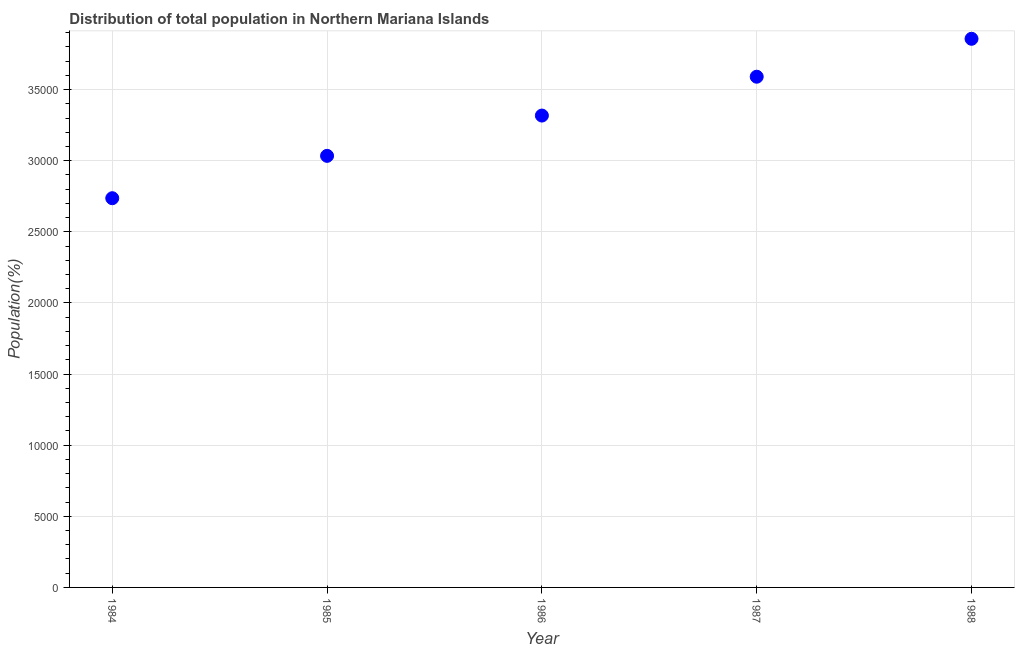What is the population in 1986?
Your answer should be compact. 3.32e+04. Across all years, what is the maximum population?
Your answer should be very brief. 3.86e+04. Across all years, what is the minimum population?
Offer a very short reply. 2.74e+04. In which year was the population maximum?
Give a very brief answer. 1988. What is the sum of the population?
Keep it short and to the point. 1.65e+05. What is the difference between the population in 1985 and 1986?
Offer a very short reply. -2832. What is the average population per year?
Provide a short and direct response. 3.31e+04. What is the median population?
Offer a very short reply. 3.32e+04. In how many years, is the population greater than 11000 %?
Your response must be concise. 5. Do a majority of the years between 1987 and 1985 (inclusive) have population greater than 24000 %?
Your answer should be compact. No. What is the ratio of the population in 1985 to that in 1988?
Ensure brevity in your answer.  0.79. Is the difference between the population in 1986 and 1987 greater than the difference between any two years?
Offer a terse response. No. What is the difference between the highest and the second highest population?
Provide a succinct answer. 2666. What is the difference between the highest and the lowest population?
Offer a terse response. 1.12e+04. Does the population monotonically increase over the years?
Offer a terse response. Yes. How many years are there in the graph?
Provide a succinct answer. 5. What is the difference between two consecutive major ticks on the Y-axis?
Ensure brevity in your answer.  5000. Does the graph contain any zero values?
Ensure brevity in your answer.  No. What is the title of the graph?
Your answer should be very brief. Distribution of total population in Northern Mariana Islands . What is the label or title of the Y-axis?
Provide a short and direct response. Population(%). What is the Population(%) in 1984?
Make the answer very short. 2.74e+04. What is the Population(%) in 1985?
Offer a terse response. 3.03e+04. What is the Population(%) in 1986?
Provide a short and direct response. 3.32e+04. What is the Population(%) in 1987?
Ensure brevity in your answer.  3.59e+04. What is the Population(%) in 1988?
Provide a short and direct response. 3.86e+04. What is the difference between the Population(%) in 1984 and 1985?
Ensure brevity in your answer.  -2978. What is the difference between the Population(%) in 1984 and 1986?
Provide a short and direct response. -5810. What is the difference between the Population(%) in 1984 and 1987?
Offer a terse response. -8541. What is the difference between the Population(%) in 1984 and 1988?
Offer a very short reply. -1.12e+04. What is the difference between the Population(%) in 1985 and 1986?
Provide a short and direct response. -2832. What is the difference between the Population(%) in 1985 and 1987?
Provide a succinct answer. -5563. What is the difference between the Population(%) in 1985 and 1988?
Make the answer very short. -8229. What is the difference between the Population(%) in 1986 and 1987?
Your answer should be very brief. -2731. What is the difference between the Population(%) in 1986 and 1988?
Offer a terse response. -5397. What is the difference between the Population(%) in 1987 and 1988?
Provide a succinct answer. -2666. What is the ratio of the Population(%) in 1984 to that in 1985?
Make the answer very short. 0.9. What is the ratio of the Population(%) in 1984 to that in 1986?
Keep it short and to the point. 0.82. What is the ratio of the Population(%) in 1984 to that in 1987?
Your answer should be very brief. 0.76. What is the ratio of the Population(%) in 1984 to that in 1988?
Offer a very short reply. 0.71. What is the ratio of the Population(%) in 1985 to that in 1986?
Your response must be concise. 0.92. What is the ratio of the Population(%) in 1985 to that in 1987?
Keep it short and to the point. 0.84. What is the ratio of the Population(%) in 1985 to that in 1988?
Give a very brief answer. 0.79. What is the ratio of the Population(%) in 1986 to that in 1987?
Your answer should be very brief. 0.92. What is the ratio of the Population(%) in 1986 to that in 1988?
Provide a succinct answer. 0.86. 